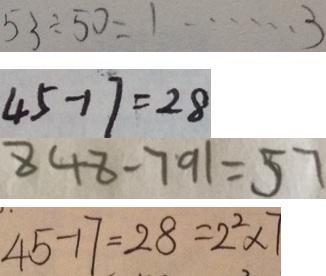Convert formula to latex. <formula><loc_0><loc_0><loc_500><loc_500>5 3 \div 5 0 = 1 \cdots 3 
 4 5 - 1 7 = 2 8 
 8 4 8 - 7 9 1 = 5 7 
 4 5 - 1 7 = 2 8 = 2 ^ { 2 } \times 7</formula> 